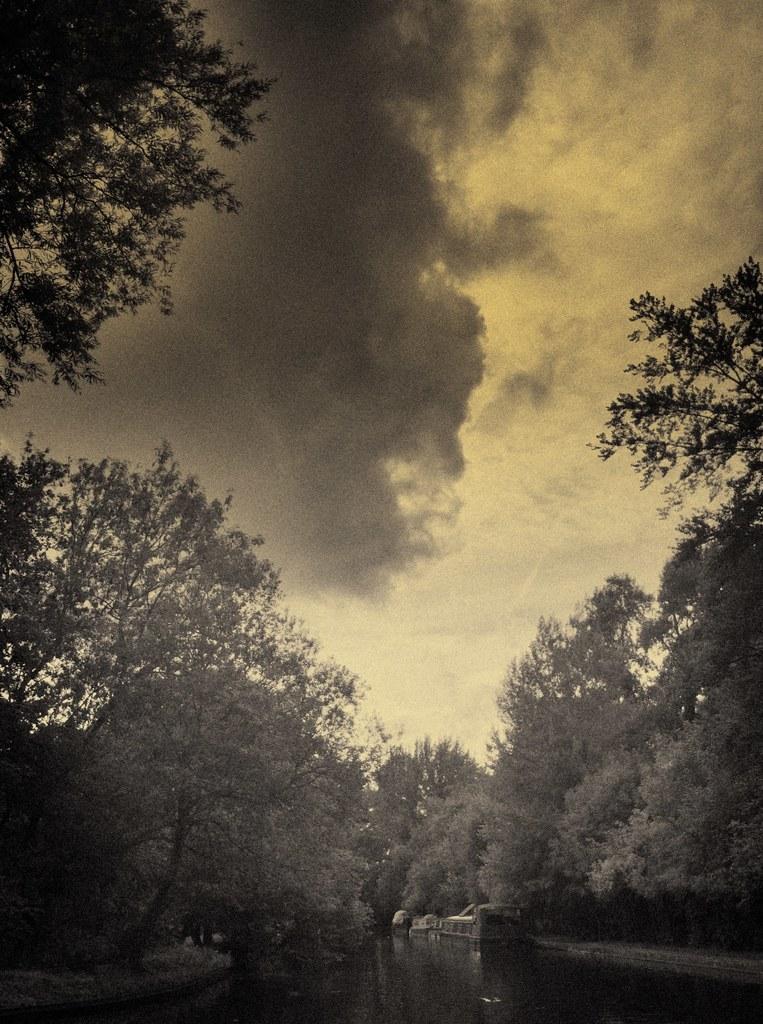How would you summarize this image in a sentence or two? In this picture there are trees. At the top there is sky and there are clouds. At the bottom there might be a boat on the water. 